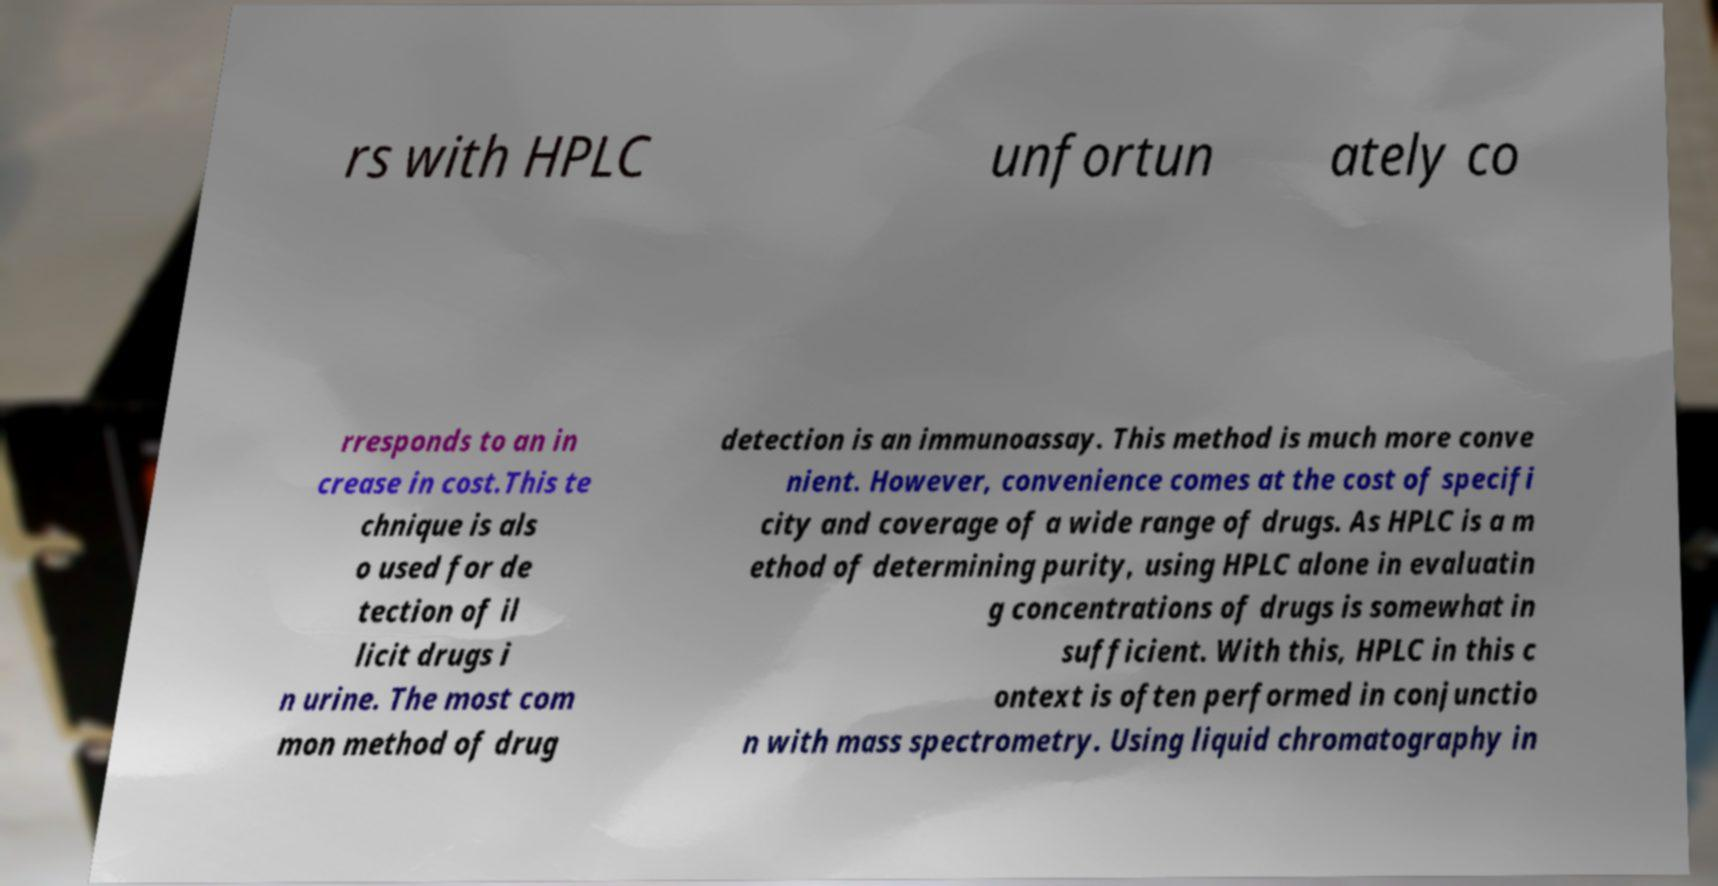Could you extract and type out the text from this image? rs with HPLC unfortun ately co rresponds to an in crease in cost.This te chnique is als o used for de tection of il licit drugs i n urine. The most com mon method of drug detection is an immunoassay. This method is much more conve nient. However, convenience comes at the cost of specifi city and coverage of a wide range of drugs. As HPLC is a m ethod of determining purity, using HPLC alone in evaluatin g concentrations of drugs is somewhat in sufficient. With this, HPLC in this c ontext is often performed in conjunctio n with mass spectrometry. Using liquid chromatography in 